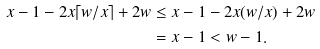<formula> <loc_0><loc_0><loc_500><loc_500>x - 1 - 2 x \lceil w / x \rceil + 2 w & \leq x - 1 - 2 x ( w / x ) + 2 w \\ & = x - 1 < w - 1 .</formula> 